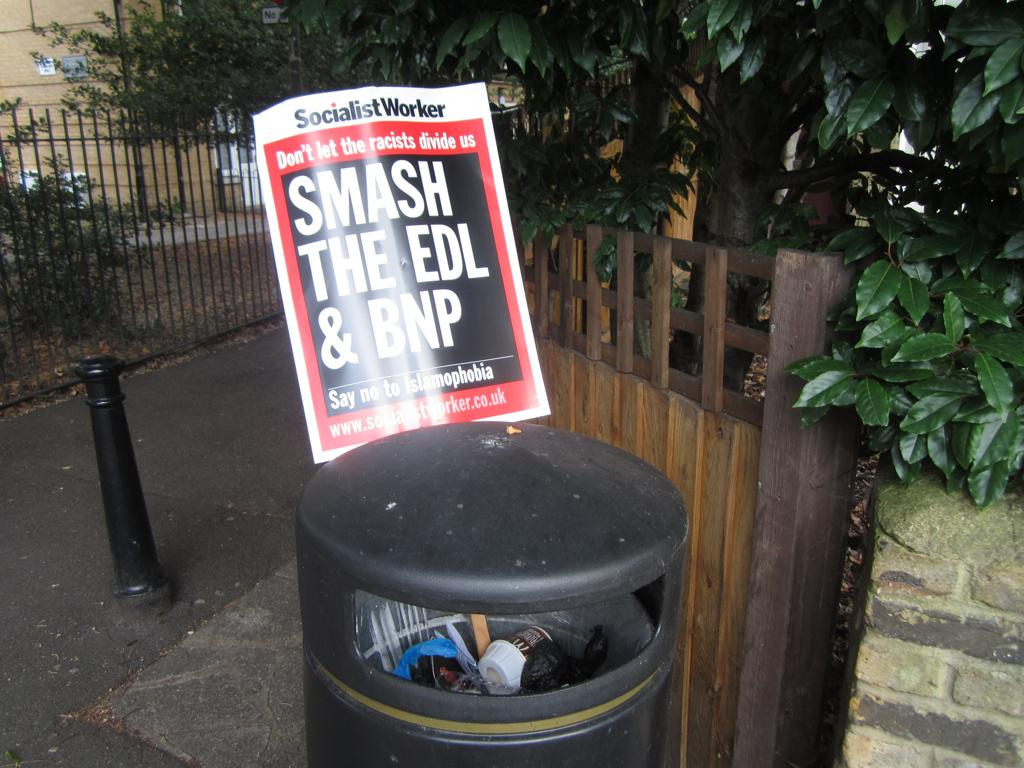<image>
Provide a brief description of the given image. A sign sticking out of a trash bin that says SMASH THE EDL & BNP. 